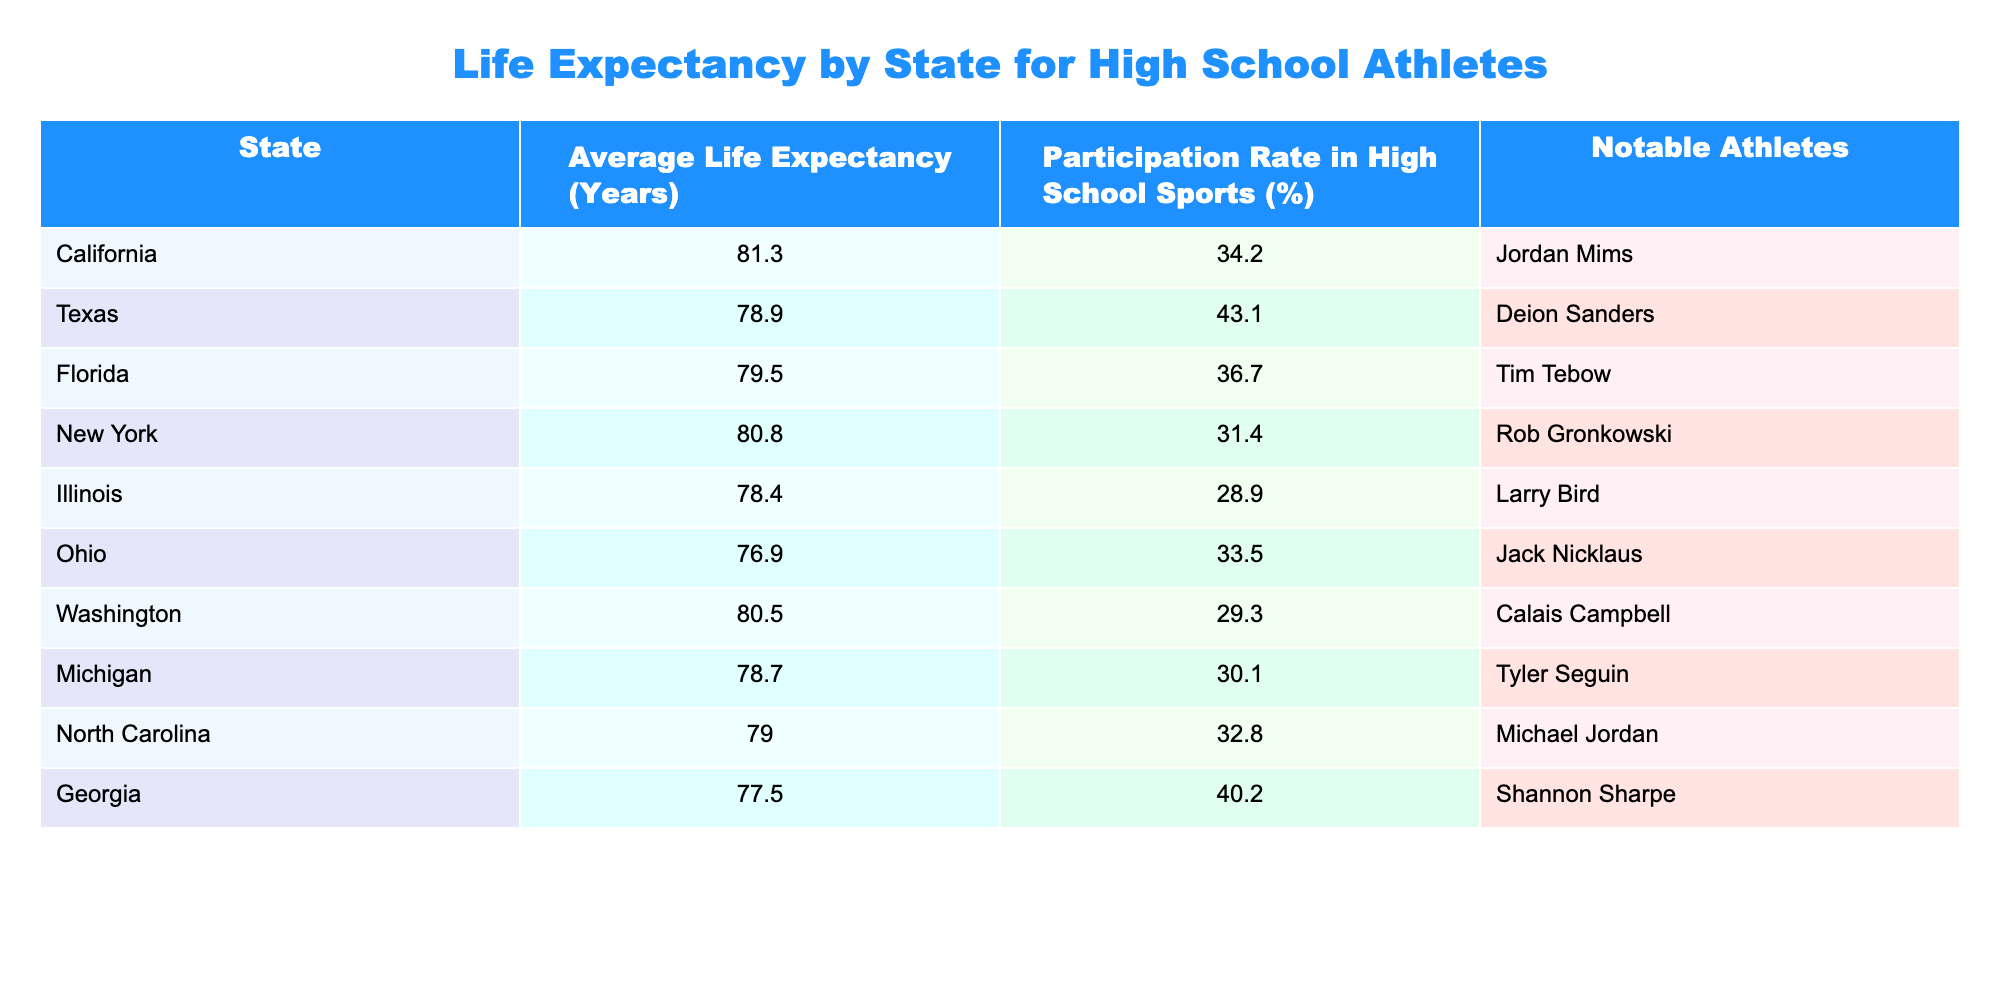What is the average life expectancy for athletes in California? The table shows that the average life expectancy for athletes in California is listed as 81.3 years.
Answer: 81.3 Which state has the highest participation rate in high school sports? According to the table, Texas has the highest participation rate at 43.1%.
Answer: Texas Is the average life expectancy for athletes in Florida higher than that in Ohio? The table shows that Florida has an average life expectancy of 79.5 years, while Ohio has 76.9 years. Since 79.5 is greater than 76.9, the answer is yes.
Answer: Yes What is the average life expectancy for athletes in the states that have a participation rate above 30%? The states with a participation rate above 30% are California (81.3), Texas (78.9), Florida (79.5), New York (80.8), North Carolina (79.0), and Georgia (77.5). To find the average, we add these values: 81.3 + 78.9 + 79.5 + 80.8 + 79.0 + 77.5 = 477.0, and then divide by 6, resulting in an average of 477.0 / 6 = 79.5.
Answer: 79.5 Does Georgia have a higher life expectancy than Michigan? Georgia's average life expectancy is 77.5 years while Michigan's is 78.7 years. Therefore, Georgia does not have a higher life expectancy than Michigan.
Answer: No Which notable athlete is listed for North Carolina? The table indicates that Michael Jordan is the notable athlete listed for North Carolina.
Answer: Michael Jordan How much lower is the average life expectancy in Ohio compared to California? California has an average life expectancy of 81.3 years, while Ohio's is 76.9 years. To find the difference, we subtract Ohio's life expectancy from California's: 81.3 - 76.9 = 4.4. Thus, Ohio’s average life expectancy is 4.4 years lower than California’s.
Answer: 4.4 years Which state has an average life expectancy of at least 80 years and a notable athlete in football? The states that meet these criteria are California (81.3 years, Jordan Mims) and New York (80.8 years, Rob Gronkowski). Therefore, both states qualify.
Answer: California and New York 